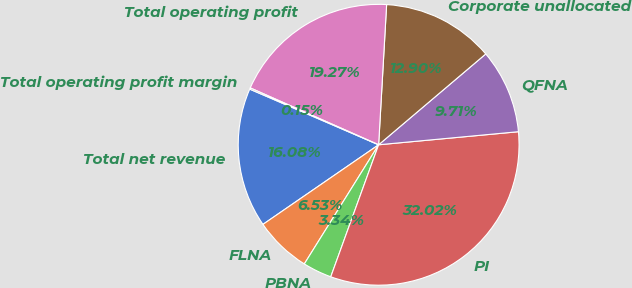Convert chart to OTSL. <chart><loc_0><loc_0><loc_500><loc_500><pie_chart><fcel>Total net revenue<fcel>FLNA<fcel>PBNA<fcel>PI<fcel>QFNA<fcel>Corporate unallocated<fcel>Total operating profit<fcel>Total operating profit margin<nl><fcel>16.08%<fcel>6.53%<fcel>3.34%<fcel>32.02%<fcel>9.71%<fcel>12.9%<fcel>19.27%<fcel>0.15%<nl></chart> 